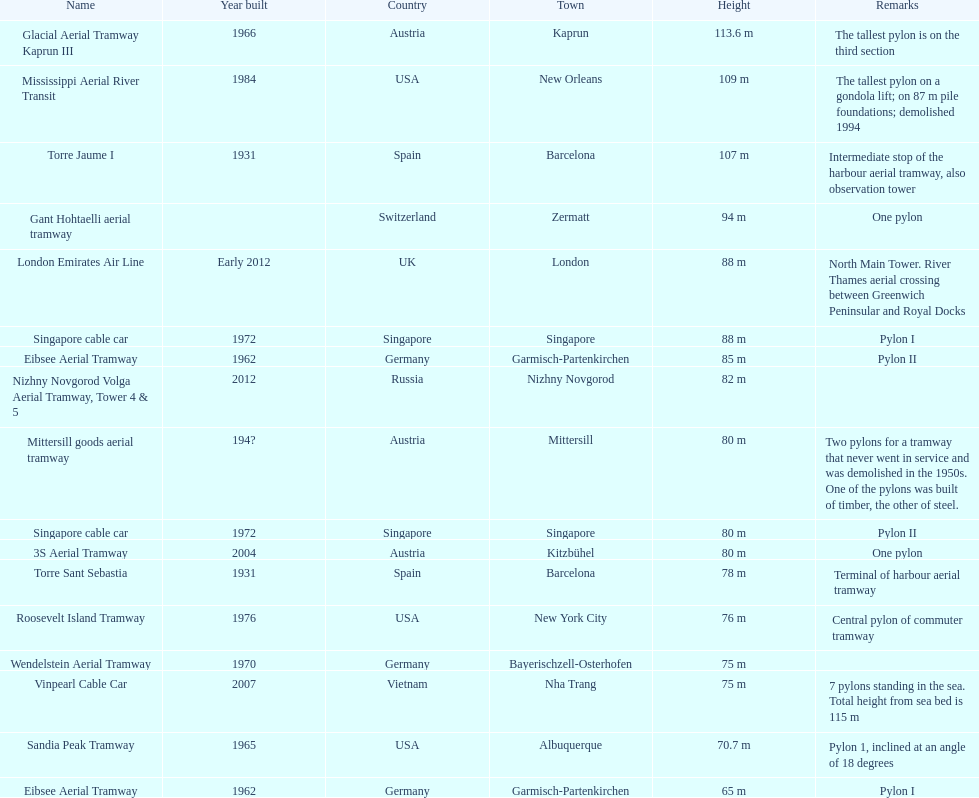In which year was the construction of the last pylon in germany completed? 1970. 